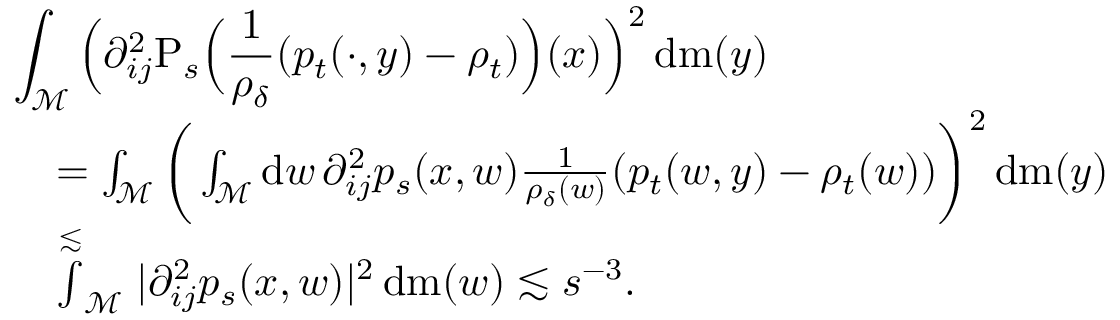<formula> <loc_0><loc_0><loc_500><loc_500>\begin{array} { r l } { { \int _ { \mathcal { M } } \left ( \partial _ { i j } ^ { 2 } P _ { s } \left ( \frac { 1 } { \rho _ { \delta } } ( p _ { t } ( \cdot , y ) - \rho _ { t } ) \right ) ( x ) \right ) ^ { 2 } \, d m ( y ) } } \\ & { = \int _ { \mathcal { M } } \left ( \int _ { \mathcal { M } } d w \, \partial _ { i j } ^ { 2 } p _ { s } ( x , w ) \frac { 1 } { \rho _ { \delta } ( w ) } ( p _ { t } ( w , y ) - \rho _ { t } ( w ) ) \right ) ^ { 2 } \, d m ( y ) } \\ & { \stackrel { \lesssim } \int _ { \mathcal { M } } | \partial _ { i j } ^ { 2 } p _ { s } ( x , w ) | ^ { 2 } \, d m ( w ) \lesssim s ^ { - 3 } . } \end{array}</formula> 